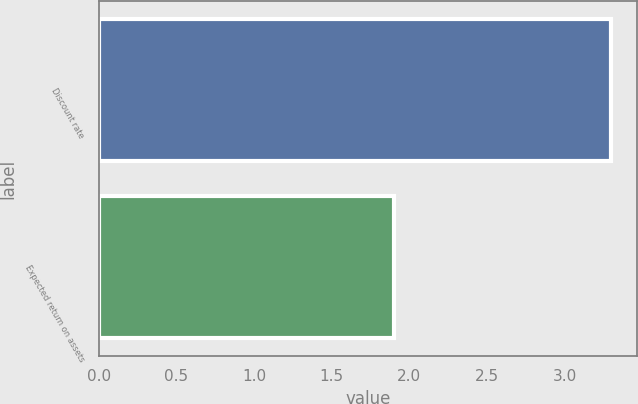Convert chart to OTSL. <chart><loc_0><loc_0><loc_500><loc_500><bar_chart><fcel>Discount rate<fcel>Expected return on assets<nl><fcel>3.3<fcel>1.9<nl></chart> 